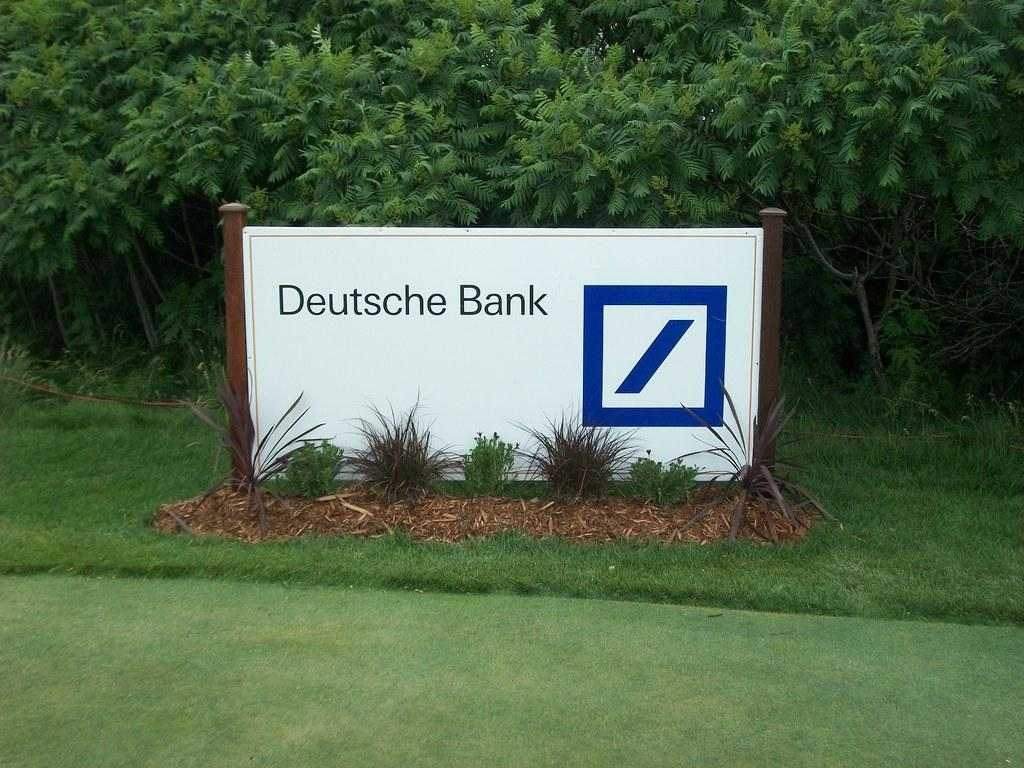What is the main object in the image? There is a name board in the image. What other elements can be seen in the image? There are plants and grass visible in the image. What can be seen in the background of the image? There are trees in the background of the image. How many pizzas are being captured by the camera in the image? There is no camera or pizza present in the image. 